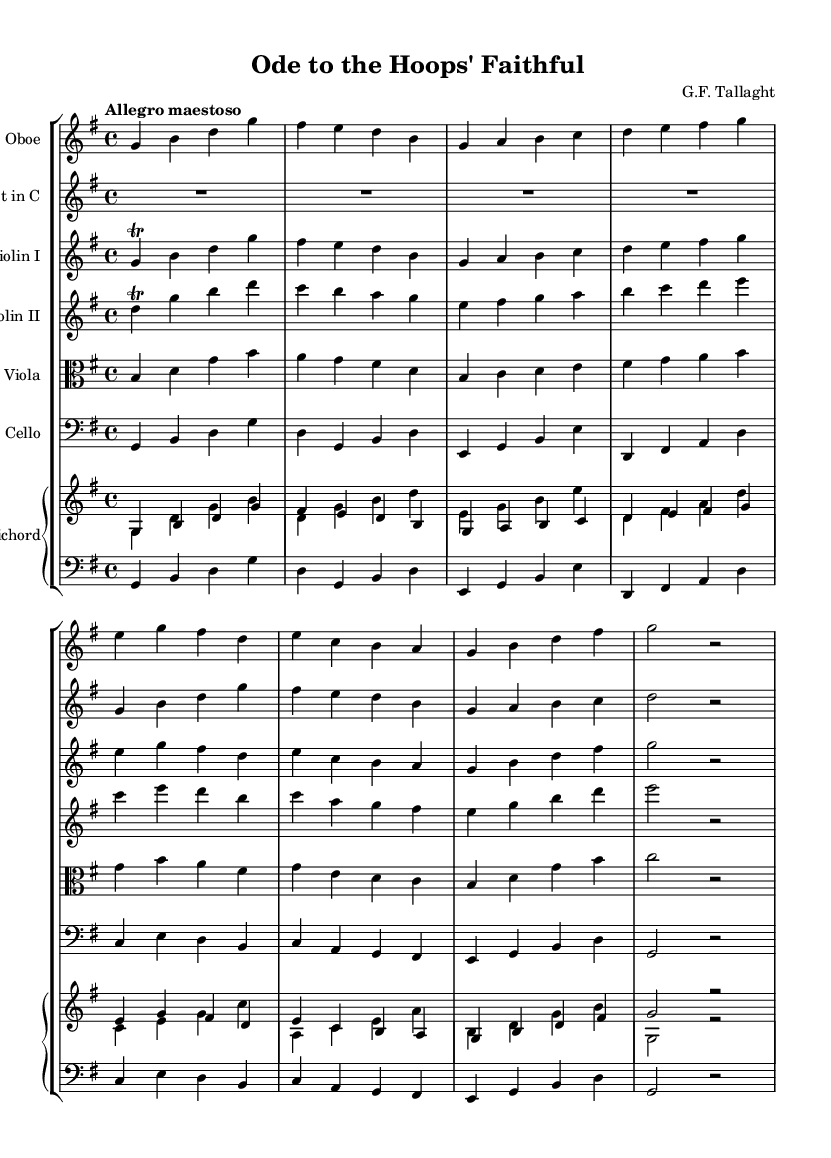What is the key signature of this music? The key signature is G major, which has one sharp (F#).
Answer: G major What is the time signature of this music? The time signature is 4/4, indicating four beats per measure.
Answer: 4/4 What is the tempo marking of the music? The tempo marking is "Allegro maestoso," indicating a fast and majestic pace.
Answer: Allegro maestoso Which instruments are featured in this score? The score features oboe, trumpet, two violins, viola, cello, and harpsichord, as indicated in the staff groups.
Answer: Oboe, trumpet, violin I, violin II, viola, cello, harpsichord How many measures are there in the oboe part? Counting the measures visually, there are eight measures in the oboe part.
Answer: Eight What is the composer's name as stated in the header? The composer's name is "G.F. Tallaght," which is indicated at the top of the score.
Answer: G.F. Tallaght Explain the significance of the trill in the violin I part. The trill in the violin I part enhances expressiveness, emphasizing the themes of loyalty and perseverance, typical in Baroque music. It adds a decorative element characteristic of the style.
Answer: Decorative element 